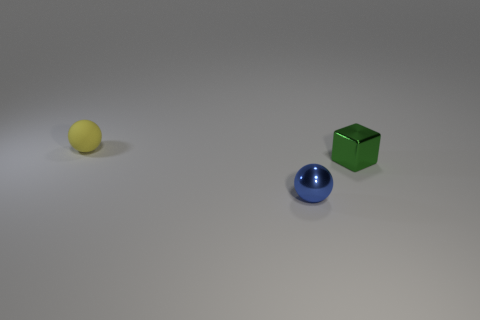Are there any other things that have the same shape as the green object?
Offer a very short reply. No. There is a green metal object that is the same size as the yellow ball; what is its shape?
Provide a succinct answer. Cube. What material is the ball that is behind the small shiny object that is to the right of the metallic thing that is to the left of the green cube?
Give a very brief answer. Rubber. Is there a green object of the same size as the blue object?
Keep it short and to the point. Yes. There is a yellow sphere that is the same size as the metal cube; what material is it?
Provide a succinct answer. Rubber. There is a thing on the left side of the metallic ball; what shape is it?
Provide a succinct answer. Sphere. Are the small ball that is to the left of the small blue object and the small ball that is in front of the green metallic cube made of the same material?
Make the answer very short. No. What number of small green metal things have the same shape as the matte object?
Give a very brief answer. 0. How many objects are either yellow rubber balls or things on the left side of the blue sphere?
Make the answer very short. 1. What is the small cube made of?
Give a very brief answer. Metal. 